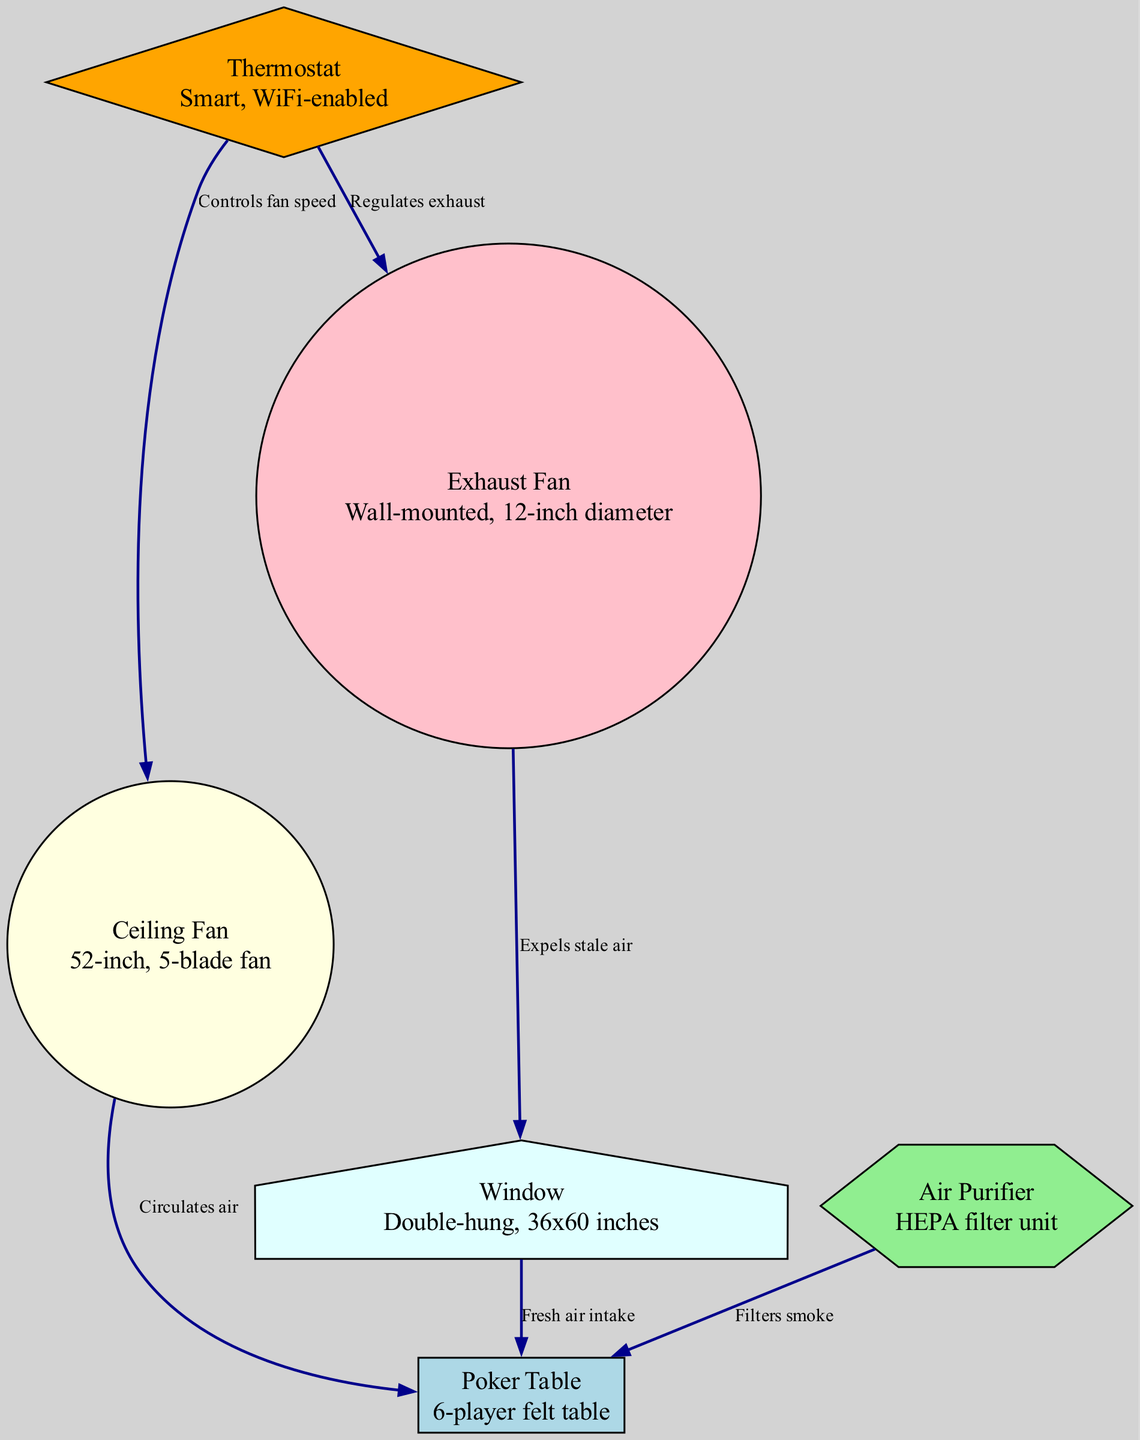What is the type of the table in the diagram? The diagram specifies that the table is named "Poker Table" and describes it as a 6-player felt table. This indicates both the name and type of table being referred to in the setup.
Answer: 6-player felt table How many nodes are depicted in the diagram? To find the number of nodes, we can count the entries listed under the "nodes" section of the provided data. There are six distinct nodes identified in this section.
Answer: 6 What component circulates air to the poker table? The diagram shows an edge labeled "Circulates air" that connects the "Ceiling Fan" to the "Poker Table." This interaction indicates that the Ceiling Fan is responsible for circulating air in that area.
Answer: Ceiling Fan Which object is responsible for filtering smoke? The diagram presents an edge that states "Filters smoke" leading from the "Air Purifier" to the "Poker Table." This relationship indicates that the Air Purifier is the object that filters smoke in the room.
Answer: Air Purifier What functionality does the thermostat provide in the ventilation system? The "Thermostat" has edges leading to both the "Ceiling Fan" and "Exhaust Fan," labeled "Controls fan speed" and "Regulates exhaust," respectively. Hence, it plays a role in adjusting both the fan and exhaust operations for optimal climate control.
Answer: Controls fan speed and regulates exhaust Where does the stale air get expelled out from? According to the edge labeled "Expels stale air," the "Exhaust Fan" is connected to the "Window." This indicates that the Exhaust Fan is responsible for expelling stale air out of the room through the window.
Answer: Window Which two components interact to allow fresh air intake? The diagram shows an edge from the "Window" to the "Poker Table," labeled "Fresh air intake." This signifies that the window, in conjunction with the poker table as its endpoint, allows for the intake of fresh air into the room.
Answer: Window What is the relationship between the exhaust fan and the window? The edge connecting the "Exhaust Fan" to the "Window" states "Expels stale air," confirming that the Exhaust Fan directly interacts with the Window to remove stale air from the room.
Answer: Expels stale air What kind of fan is indicated in the diagram and how is it described? The "Ceiling Fan" is specified as being a 52-inch, 5-blade fan, as detailed in the description provided in the nodes. This identifies its size and blade count, significant features of this component.
Answer: 52-inch, 5-blade fan 